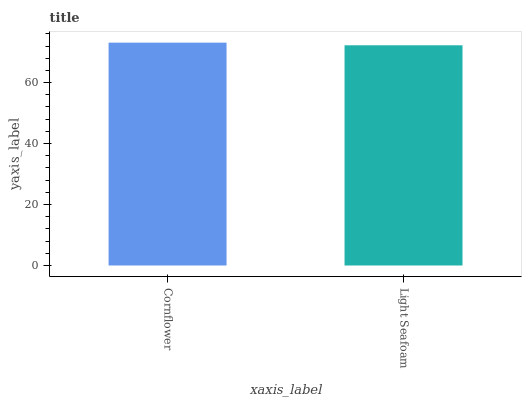Is Light Seafoam the minimum?
Answer yes or no. Yes. Is Cornflower the maximum?
Answer yes or no. Yes. Is Light Seafoam the maximum?
Answer yes or no. No. Is Cornflower greater than Light Seafoam?
Answer yes or no. Yes. Is Light Seafoam less than Cornflower?
Answer yes or no. Yes. Is Light Seafoam greater than Cornflower?
Answer yes or no. No. Is Cornflower less than Light Seafoam?
Answer yes or no. No. Is Cornflower the high median?
Answer yes or no. Yes. Is Light Seafoam the low median?
Answer yes or no. Yes. Is Light Seafoam the high median?
Answer yes or no. No. Is Cornflower the low median?
Answer yes or no. No. 